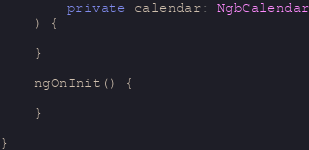Convert code to text. <code><loc_0><loc_0><loc_500><loc_500><_TypeScript_>        private calendar: NgbCalendar
    ) {

    }

    ngOnInit() {

    }

}
</code> 